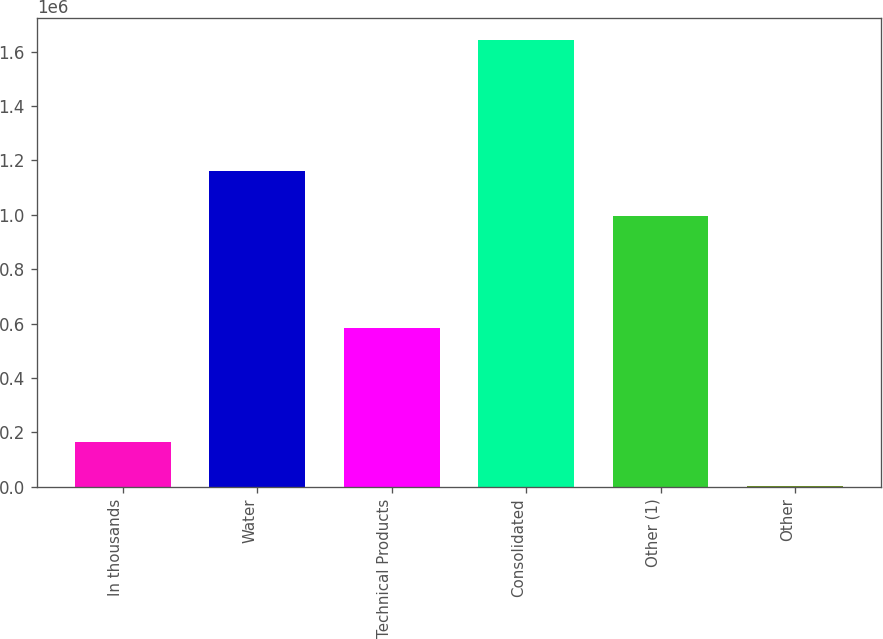Convert chart. <chart><loc_0><loc_0><loc_500><loc_500><bar_chart><fcel>In thousands<fcel>Water<fcel>Technical Products<fcel>Consolidated<fcel>Other (1)<fcel>Other<nl><fcel>165348<fcel>1.16089e+06<fcel>582684<fcel>1.64299e+06<fcel>996712<fcel>1166<nl></chart> 